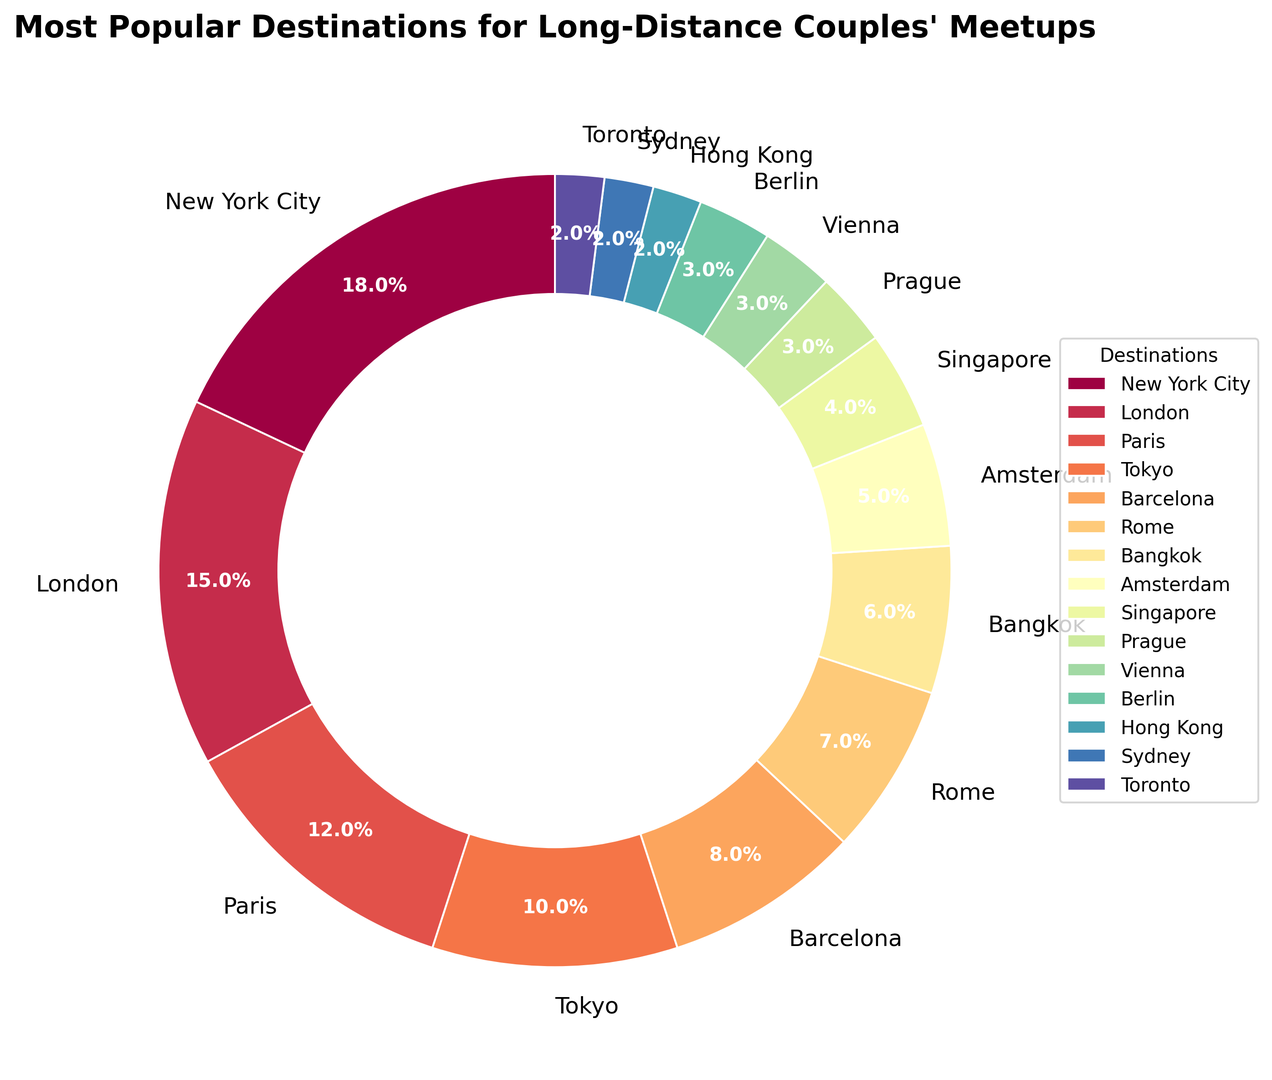What's the most popular meetup destination for long-distance couples? The largest segment of the pie chart represents the most popular destination. In this case, New York City has the largest percentage, which is 18%.
Answer: New York City Which destination has a higher percentage, Paris or Tokyo? By comparing the percentage labels on the pie chart, Paris has 12% and Tokyo has 10%. Since 12% is greater than 10%, Paris has a higher percentage.
Answer: Paris What is the combined percentage share of London and Paris? London has 15% and Paris has 12%. Adding these together: 15% + 12% = 27%.
Answer: 27% Which three destinations have the least percentage of meetups? The smallest segments in the pie chart represent Hong Kong, Sydney, and Toronto, each with 2% each.
Answer: Hong Kong, Sydney, Toronto How much more popular is New York City compared to Amsterdam? New York City has 18% and Amsterdam has 5%. The difference is 18% - 5% = 13%.
Answer: 13% Are there any destinations with equal percentage shares? If so, which ones? The pie chart shows that Prague, Vienna, and Berlin each have a percentage of 3%.
Answer: Prague, Vienna, Berlin What percentage of meetups are in European cities? To find this, add the percentages of London (15%), Paris (12%), Barcelona (8%), Rome (7%), Amsterdam (5%), Prague (3%), Vienna (3%), Berlin (3%): 15% + 12% + 8% + 7% + 5% + 3% + 3% + 3% = 56%.
Answer: 56% What is the average percentage share of all the destinations listed? There are 15 destinations in total. Summing their percentages: 18 + 15 + 12 + 10 + 8 + 7 + 6 + 5 + 4 + 3 + 3 + 3 + 2 + 2 + 2 = 100%. The average is 100% / 15 = 6.67%.
Answer: 6.67% Which destination represents exactly one-sixth of the total percentage? One-sixth of 100% is approximately 16.67%. London, with 15%, is the closest destination to this value.
Answer: London If the meetups in Tokyo were to increase by 50%, what would be the new percentage for Tokyo? Tokyo currently has 10%. Increasing this by 50%: 10% * 1.5 = 15%.
Answer: 15% 